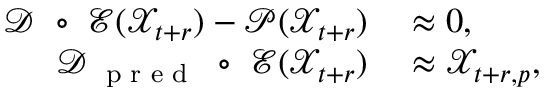Convert formula to latex. <formula><loc_0><loc_0><loc_500><loc_500>\begin{array} { r l } { \mathcal { D } \circ \mathcal { E } ( \mathcal { X } _ { t + r } ) - \mathcal { P } ( \mathcal { X } _ { t + r } ) } & \approx \boldsymbol 0 , } \\ { \mathcal { D } _ { p r e d } \circ \mathcal { E } ( \mathcal { X } _ { t + r } ) } & \approx \ m a t h s c r X _ { t + r , p } , } \end{array}</formula> 